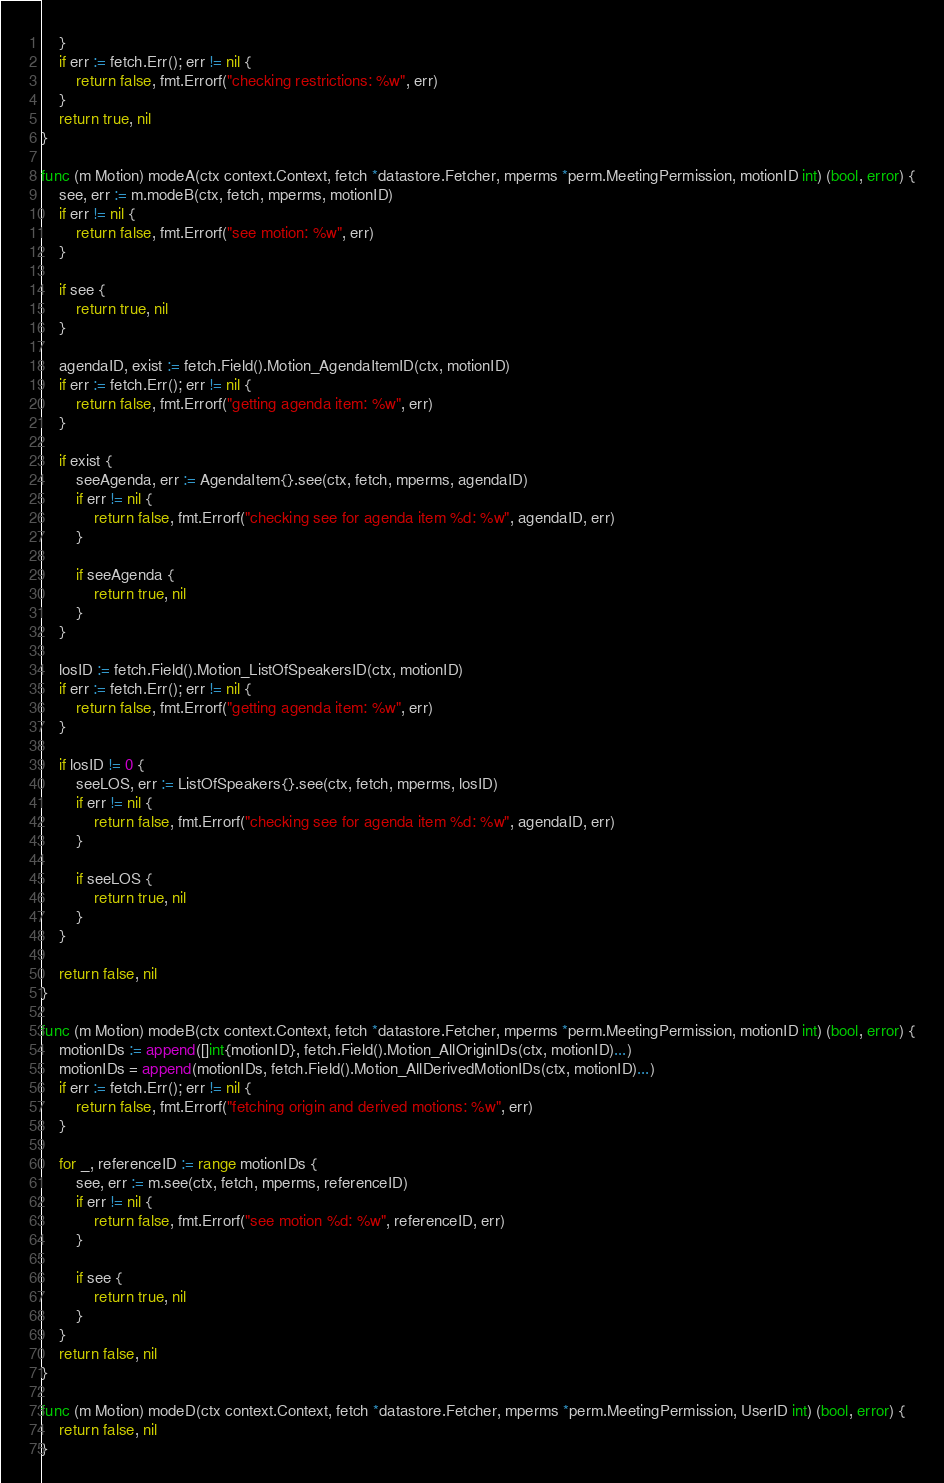Convert code to text. <code><loc_0><loc_0><loc_500><loc_500><_Go_>	}
	if err := fetch.Err(); err != nil {
		return false, fmt.Errorf("checking restrictions: %w", err)
	}
	return true, nil
}

func (m Motion) modeA(ctx context.Context, fetch *datastore.Fetcher, mperms *perm.MeetingPermission, motionID int) (bool, error) {
	see, err := m.modeB(ctx, fetch, mperms, motionID)
	if err != nil {
		return false, fmt.Errorf("see motion: %w", err)
	}

	if see {
		return true, nil
	}

	agendaID, exist := fetch.Field().Motion_AgendaItemID(ctx, motionID)
	if err := fetch.Err(); err != nil {
		return false, fmt.Errorf("getting agenda item: %w", err)
	}

	if exist {
		seeAgenda, err := AgendaItem{}.see(ctx, fetch, mperms, agendaID)
		if err != nil {
			return false, fmt.Errorf("checking see for agenda item %d: %w", agendaID, err)
		}

		if seeAgenda {
			return true, nil
		}
	}

	losID := fetch.Field().Motion_ListOfSpeakersID(ctx, motionID)
	if err := fetch.Err(); err != nil {
		return false, fmt.Errorf("getting agenda item: %w", err)
	}

	if losID != 0 {
		seeLOS, err := ListOfSpeakers{}.see(ctx, fetch, mperms, losID)
		if err != nil {
			return false, fmt.Errorf("checking see for agenda item %d: %w", agendaID, err)
		}

		if seeLOS {
			return true, nil
		}
	}

	return false, nil
}

func (m Motion) modeB(ctx context.Context, fetch *datastore.Fetcher, mperms *perm.MeetingPermission, motionID int) (bool, error) {
	motionIDs := append([]int{motionID}, fetch.Field().Motion_AllOriginIDs(ctx, motionID)...)
	motionIDs = append(motionIDs, fetch.Field().Motion_AllDerivedMotionIDs(ctx, motionID)...)
	if err := fetch.Err(); err != nil {
		return false, fmt.Errorf("fetching origin and derived motions: %w", err)
	}

	for _, referenceID := range motionIDs {
		see, err := m.see(ctx, fetch, mperms, referenceID)
		if err != nil {
			return false, fmt.Errorf("see motion %d: %w", referenceID, err)
		}

		if see {
			return true, nil
		}
	}
	return false, nil
}

func (m Motion) modeD(ctx context.Context, fetch *datastore.Fetcher, mperms *perm.MeetingPermission, UserID int) (bool, error) {
	return false, nil
}
</code> 